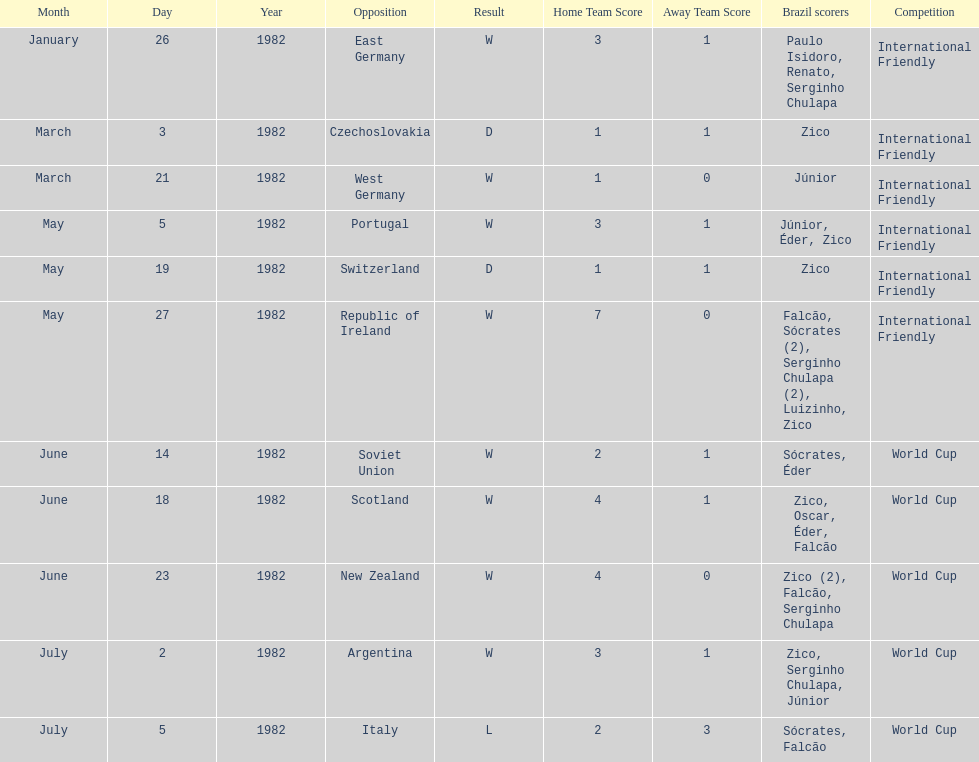Did brazil score more goals against the soviet union or portugal in 1982? Portugal. 